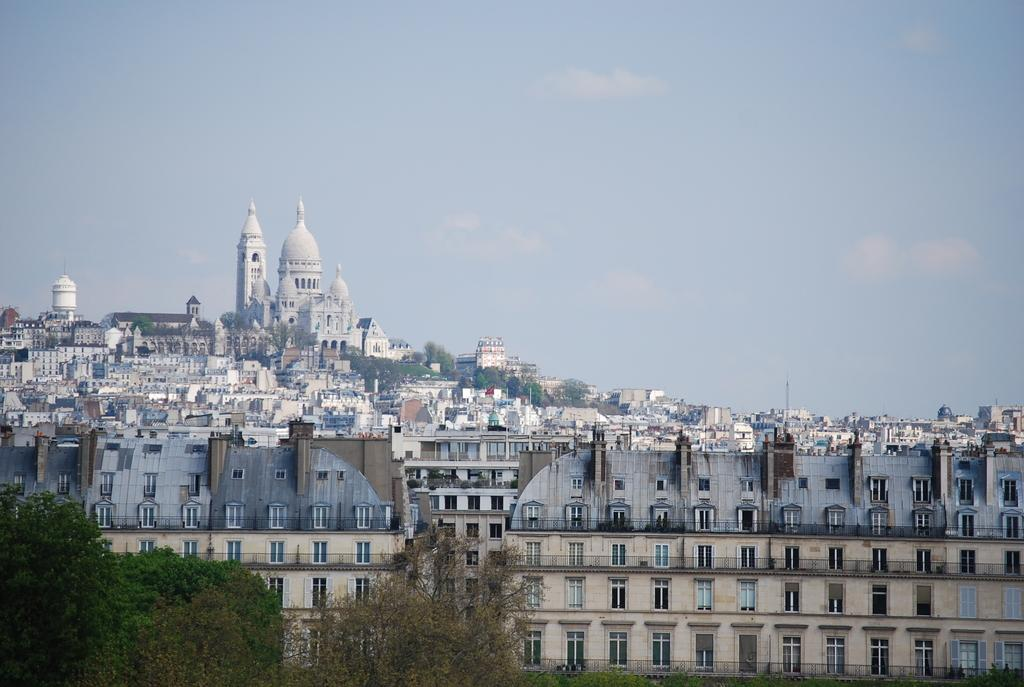What type of vegetation can be seen in the image? There are trees in the image. What type of structures are present in the image? There are buildings in the image. What is visible in the background of the image? The sky is visible in the background of the image. What type of cushion can be seen on the roof of the building in the image? There is no cushion visible on the roof of any building in the image. 